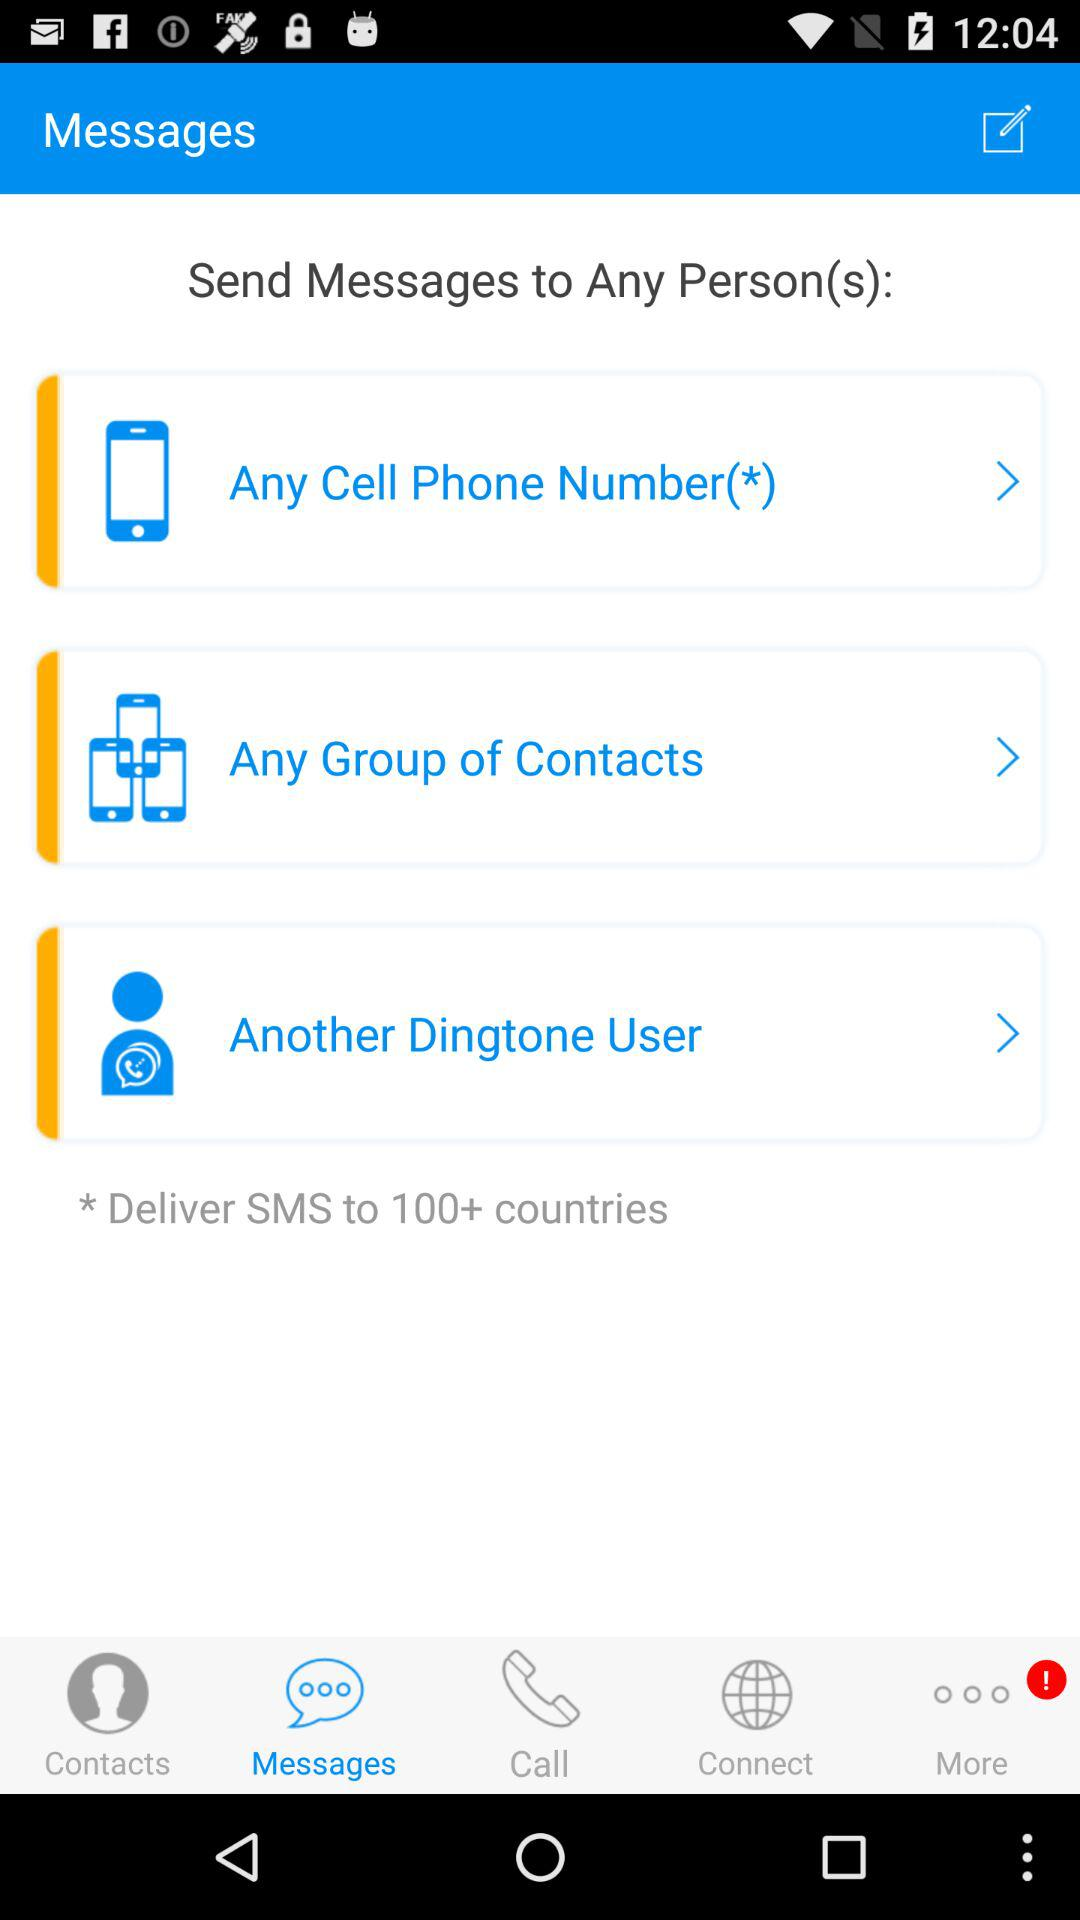How many ways can I send a message?
Answer the question using a single word or phrase. 3 